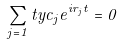<formula> <loc_0><loc_0><loc_500><loc_500>\sum _ { j = 1 } ^ { \ } t y c _ { j } e ^ { i r _ { j } t } = 0</formula> 